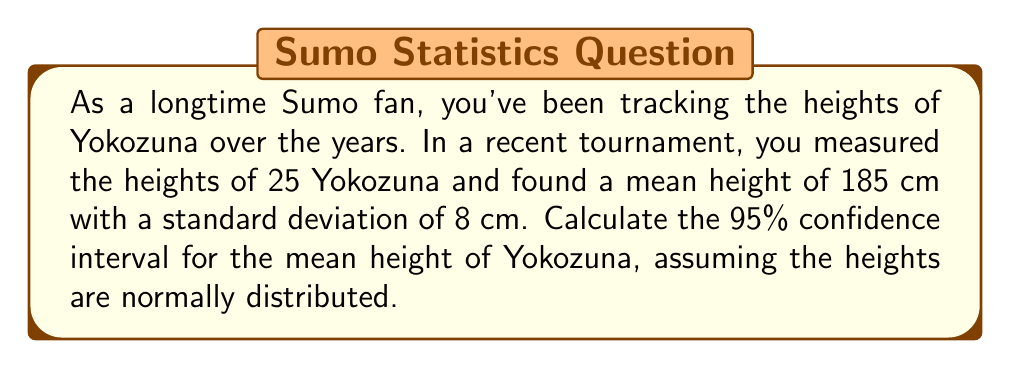Can you solve this math problem? Let's approach this step-by-step:

1) We're dealing with a small sample size (n < 30), so we'll use the t-distribution.

2) We have the following information:
   - Sample size (n) = 25
   - Sample mean ($\bar{x}$) = 185 cm
   - Sample standard deviation (s) = 8 cm
   - Confidence level = 95%

3) The formula for the confidence interval is:

   $$\bar{x} \pm t_{\alpha/2} \cdot \frac{s}{\sqrt{n}}$$

   where $t_{\alpha/2}$ is the t-value for the given confidence level and degrees of freedom.

4) Degrees of freedom (df) = n - 1 = 25 - 1 = 24

5) For a 95% confidence interval, $\alpha = 0.05$, and $\alpha/2 = 0.025$

6) Looking up the t-value for df = 24 and $\alpha/2 = 0.025$, we get:
   $t_{0.025} = 2.064$

7) Now, let's substitute these values into our formula:

   $$185 \pm 2.064 \cdot \frac{8}{\sqrt{25}}$$

8) Simplify:
   $$185 \pm 2.064 \cdot \frac{8}{5} = 185 \pm 3.3024$$

9) Calculate the interval:
   $185 - 3.3024 = 181.6976$
   $185 + 3.3024 = 188.3024$

Therefore, the 95% confidence interval for the mean height of Yokozuna is (181.70 cm, 188.30 cm).
Answer: (181.70 cm, 188.30 cm) 